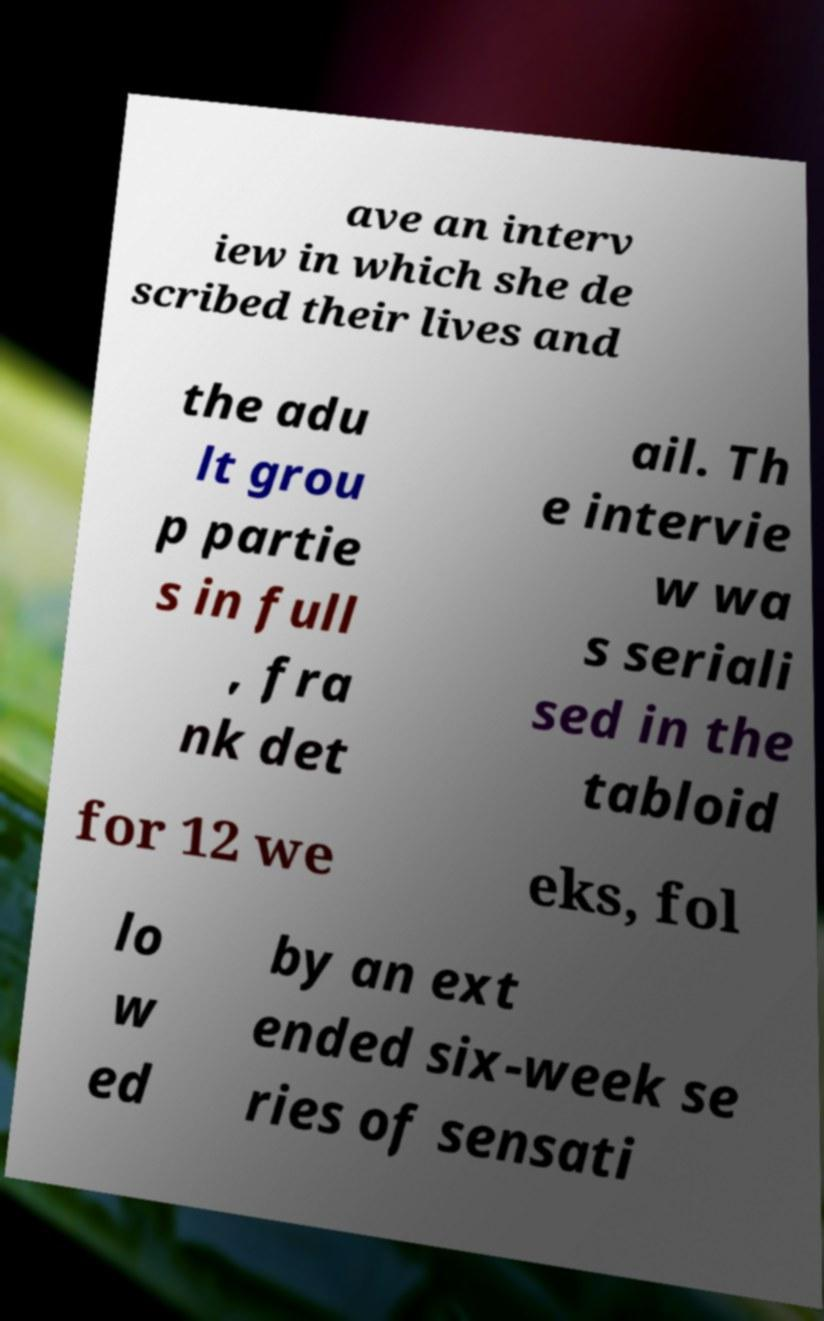I need the written content from this picture converted into text. Can you do that? ave an interv iew in which she de scribed their lives and the adu lt grou p partie s in full , fra nk det ail. Th e intervie w wa s seriali sed in the tabloid for 12 we eks, fol lo w ed by an ext ended six-week se ries of sensati 